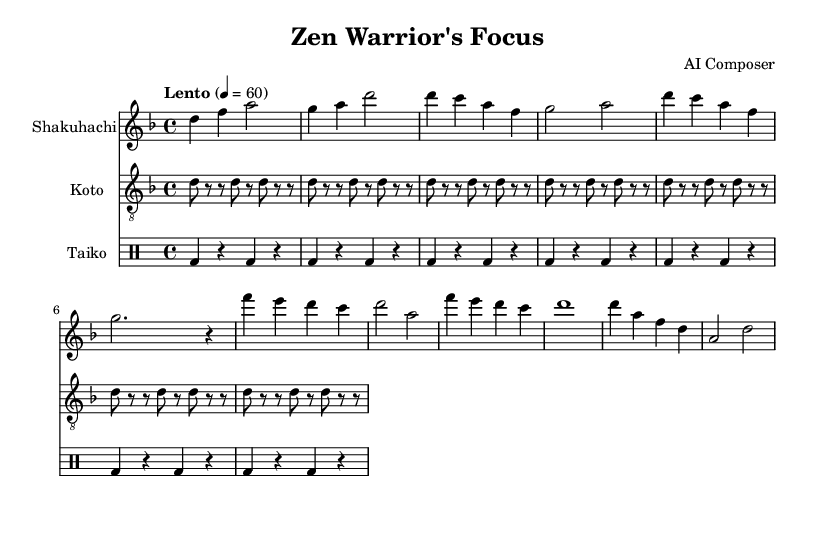What is the key signature of this music? The key signature is indicated by the presence of one flat sign on the staff, which corresponds to the key of D minor.
Answer: D minor What is the time signature of this music? The time signature is shown at the beginning of the sheet music with the two numbers placed one above the other, indicating that there are four beats in each measure.
Answer: 4/4 What is the tempo marking of the piece? The tempo marking is given in Italian above the staff, stating "Lento" with a metronome marking of 60 beats per minute, indicating a slow pace.
Answer: Lento How many measures are there in the Shakuhachi part? By counting each group separated by vertical lines, the total number of measures in the Shakuhachi part is determined. There are 10 measures.
Answer: 10 What instrument plays the accompaniment pattern? The accompaniment pattern is noted on the staff labeled "Koto," which features a repeated sequence of notes.
Answer: Koto Which instrument plays a simple taiko pattern? The rhythm pattern is indicated on the staff labeled as "Taiko," which uses specific symbols for the drums.
Answer: Taiko What section follows the Theme A in the Shakuhachi part? Analyzing the form of the piece, after Theme A, which spans the first several measures, the next section is identified as Theme B.
Answer: Theme B 